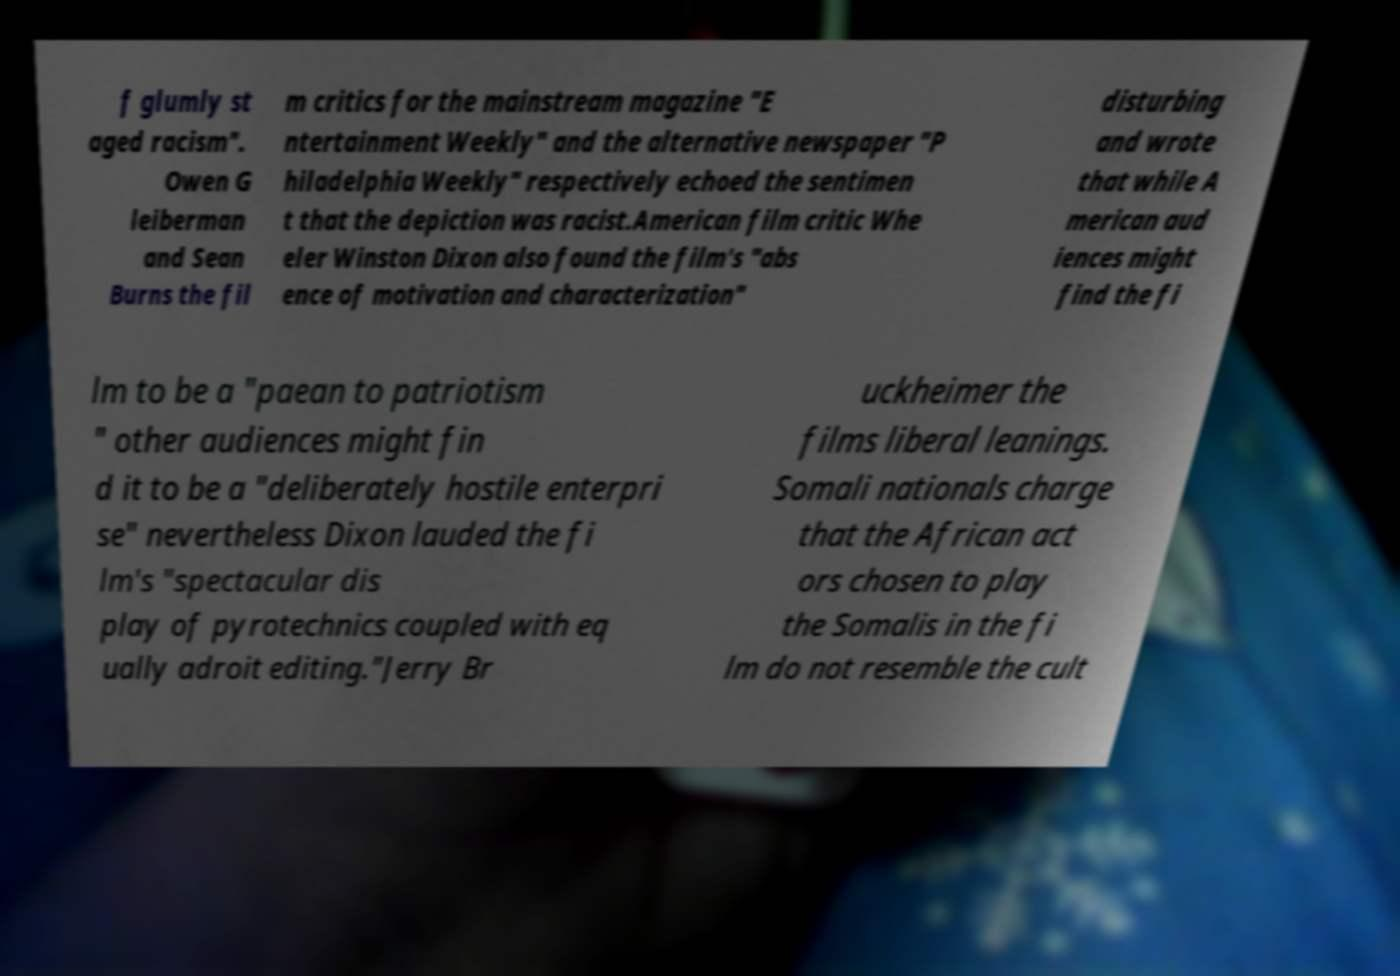Could you assist in decoding the text presented in this image and type it out clearly? f glumly st aged racism". Owen G leiberman and Sean Burns the fil m critics for the mainstream magazine "E ntertainment Weekly" and the alternative newspaper "P hiladelphia Weekly" respectively echoed the sentimen t that the depiction was racist.American film critic Whe eler Winston Dixon also found the film's "abs ence of motivation and characterization" disturbing and wrote that while A merican aud iences might find the fi lm to be a "paean to patriotism " other audiences might fin d it to be a "deliberately hostile enterpri se" nevertheless Dixon lauded the fi lm's "spectacular dis play of pyrotechnics coupled with eq ually adroit editing."Jerry Br uckheimer the films liberal leanings. Somali nationals charge that the African act ors chosen to play the Somalis in the fi lm do not resemble the cult 